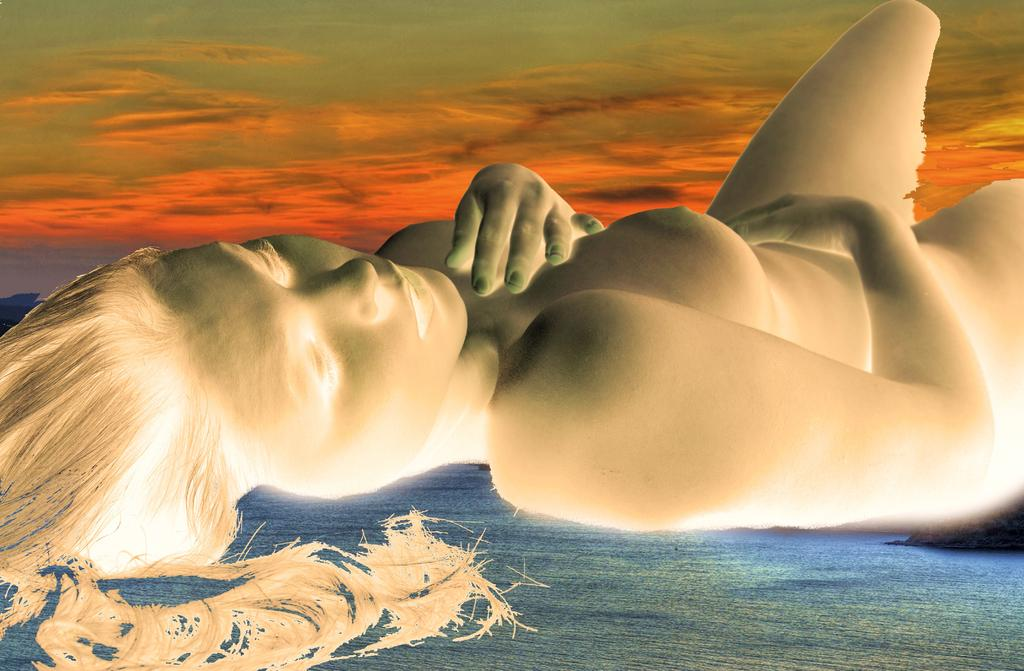What type of image is being described? The image is animated. What is the woman doing in the image? The woman is lying on a surface in the image. What can be seen in the background of the image? The sky is visible at the top of the image. What color is the chalk used by the woman in the image? There is no chalk present in the image. How does the woman slip on the surface in the image? The woman is not shown slipping in the image; she is lying on the surface. 